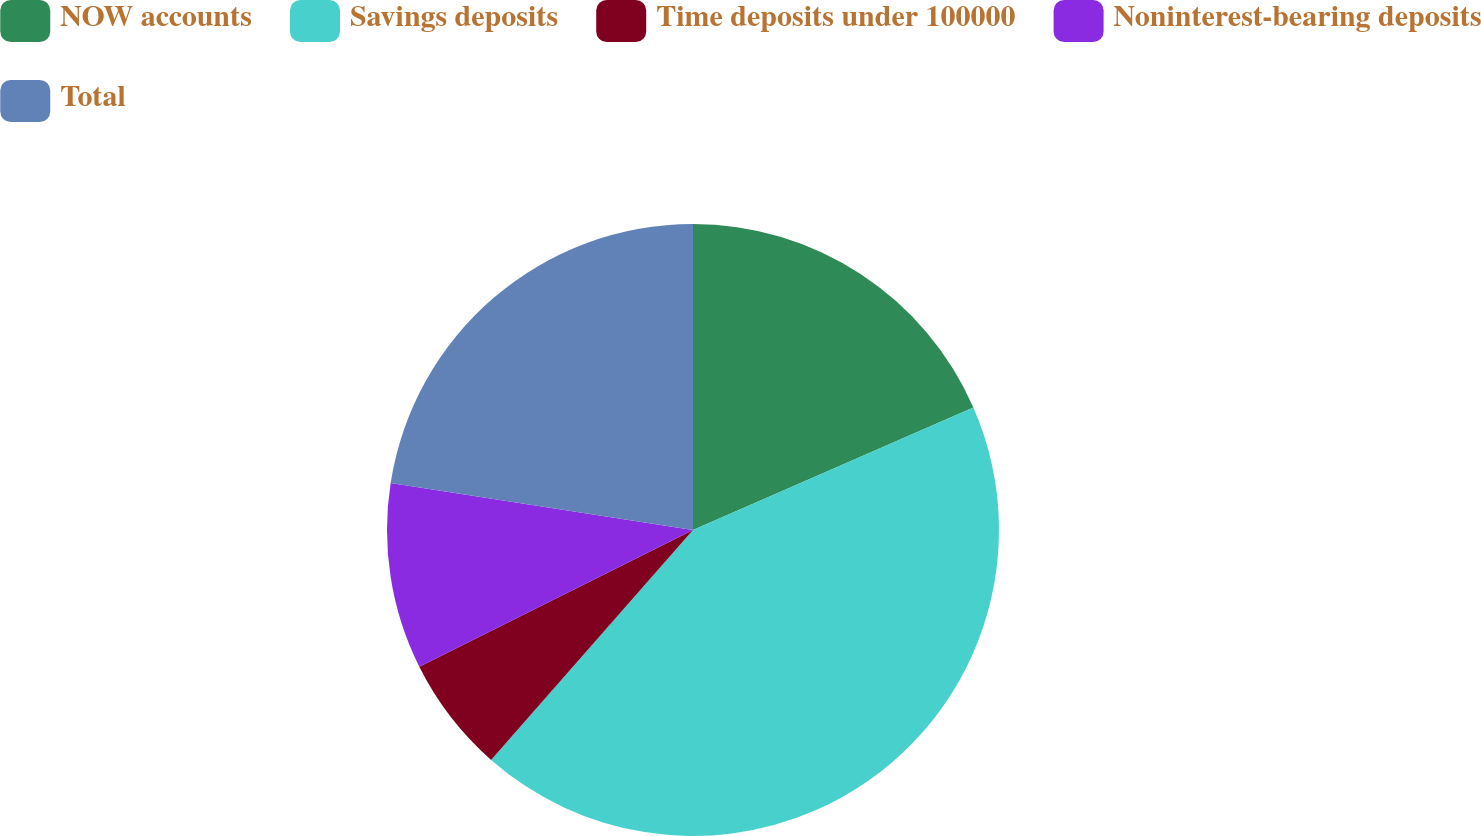Convert chart to OTSL. <chart><loc_0><loc_0><loc_500><loc_500><pie_chart><fcel>NOW accounts<fcel>Savings deposits<fcel>Time deposits under 100000<fcel>Noninterest-bearing deposits<fcel>Total<nl><fcel>18.44%<fcel>43.03%<fcel>6.15%<fcel>9.84%<fcel>22.54%<nl></chart> 